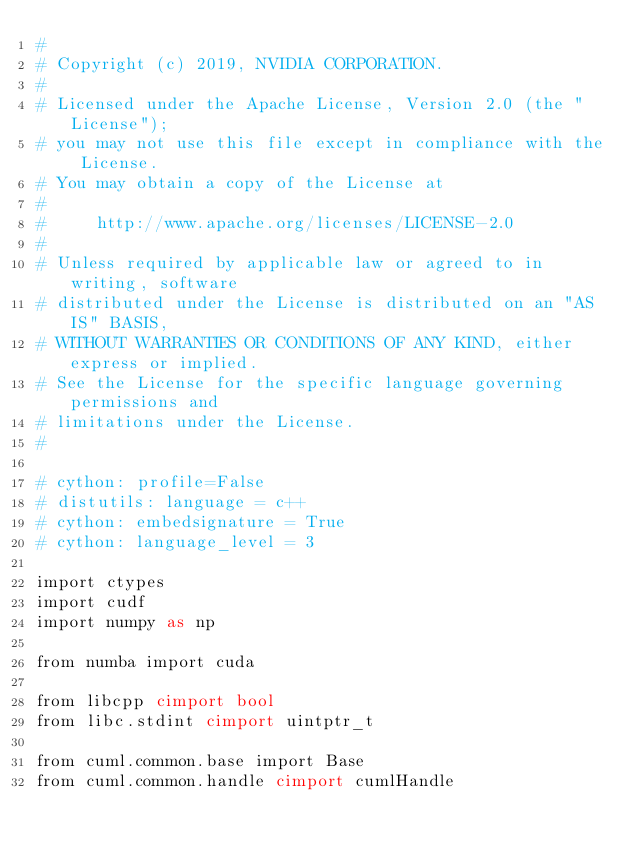Convert code to text. <code><loc_0><loc_0><loc_500><loc_500><_Cython_>#
# Copyright (c) 2019, NVIDIA CORPORATION.
#
# Licensed under the Apache License, Version 2.0 (the "License");
# you may not use this file except in compliance with the License.
# You may obtain a copy of the License at
#
#     http://www.apache.org/licenses/LICENSE-2.0
#
# Unless required by applicable law or agreed to in writing, software
# distributed under the License is distributed on an "AS IS" BASIS,
# WITHOUT WARRANTIES OR CONDITIONS OF ANY KIND, either express or implied.
# See the License for the specific language governing permissions and
# limitations under the License.
#

# cython: profile=False
# distutils: language = c++
# cython: embedsignature = True
# cython: language_level = 3

import ctypes
import cudf
import numpy as np

from numba import cuda

from libcpp cimport bool
from libc.stdint cimport uintptr_t

from cuml.common.base import Base
from cuml.common.handle cimport cumlHandle</code> 